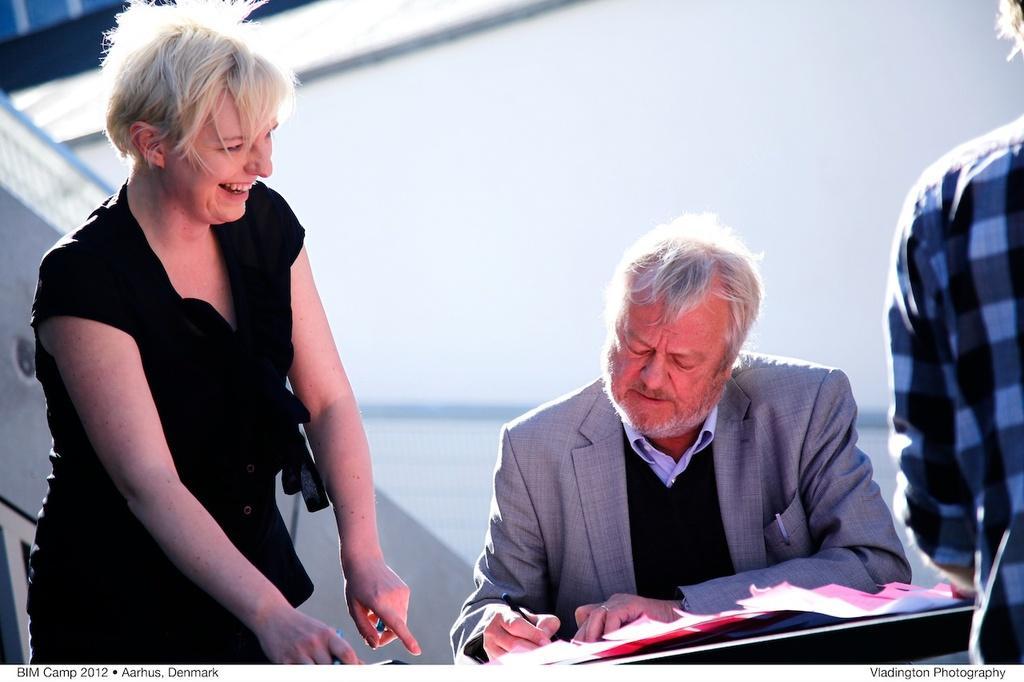In one or two sentences, can you explain what this image depicts? In this image, we can see a man sitting and he is holding a pen, we can see some papers, on the left side, we can see a woman standing and she is smiling, on the right side we can see a person standing. 